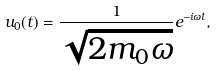Convert formula to latex. <formula><loc_0><loc_0><loc_500><loc_500>u _ { 0 } ( t ) = \frac { 1 } { \sqrt { 2 m _ { 0 } \omega } } e ^ { - i \omega t } ,</formula> 